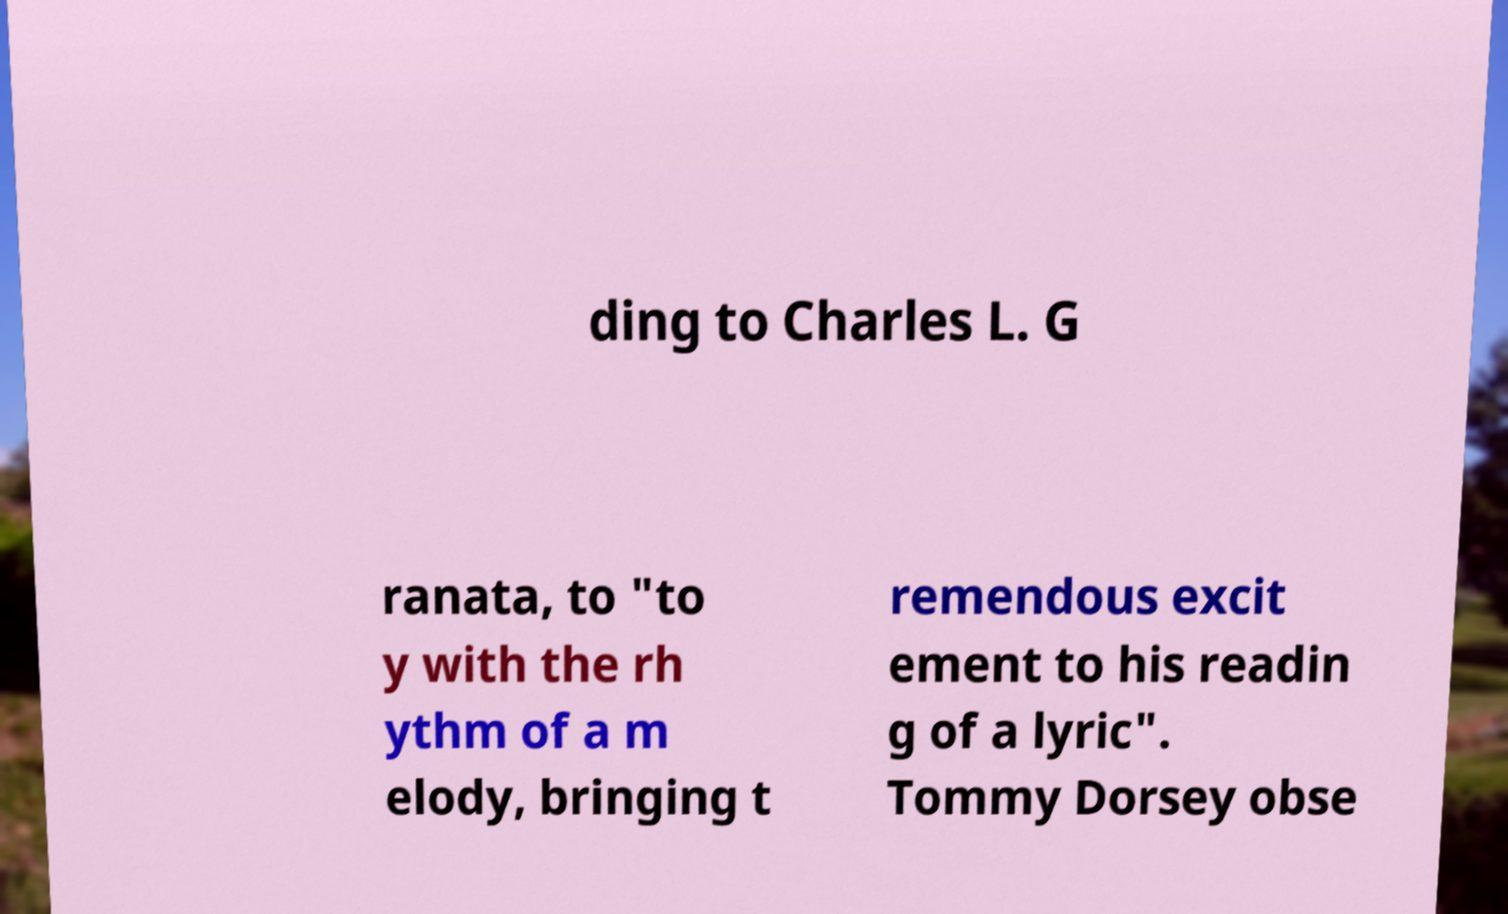Please identify and transcribe the text found in this image. ding to Charles L. G ranata, to "to y with the rh ythm of a m elody, bringing t remendous excit ement to his readin g of a lyric". Tommy Dorsey obse 